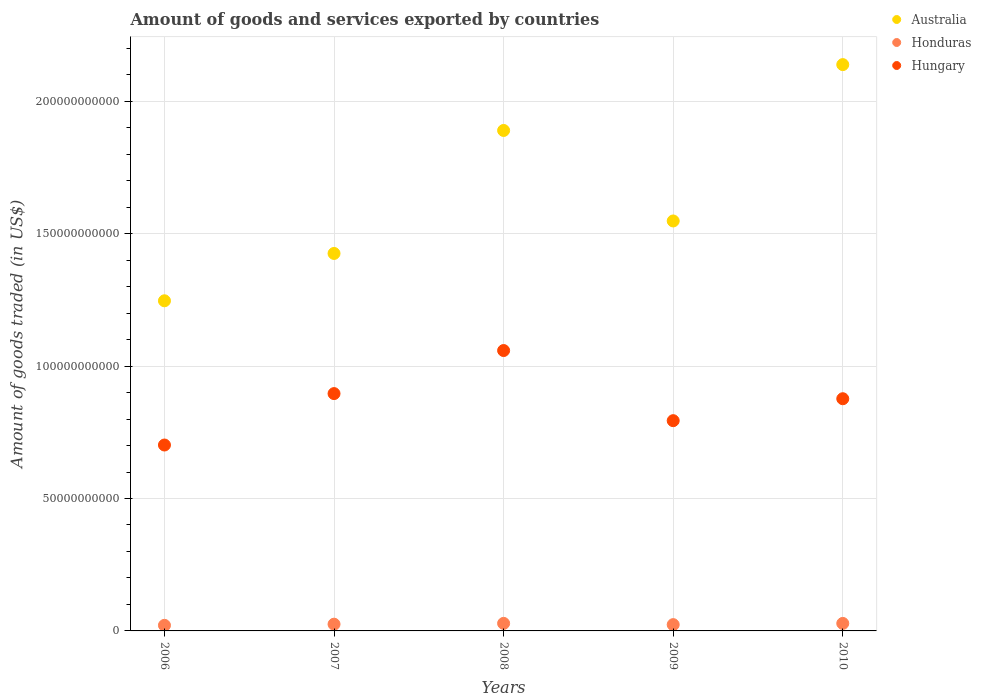How many different coloured dotlines are there?
Make the answer very short. 3. What is the total amount of goods and services exported in Honduras in 2007?
Offer a terse response. 2.54e+09. Across all years, what is the maximum total amount of goods and services exported in Honduras?
Provide a short and direct response. 2.85e+09. Across all years, what is the minimum total amount of goods and services exported in Australia?
Offer a very short reply. 1.25e+11. In which year was the total amount of goods and services exported in Honduras maximum?
Make the answer very short. 2008. What is the total total amount of goods and services exported in Australia in the graph?
Your answer should be very brief. 8.25e+11. What is the difference between the total amount of goods and services exported in Australia in 2007 and that in 2008?
Provide a succinct answer. -4.64e+1. What is the difference between the total amount of goods and services exported in Honduras in 2006 and the total amount of goods and services exported in Australia in 2008?
Offer a terse response. -1.87e+11. What is the average total amount of goods and services exported in Honduras per year?
Your answer should be compact. 2.54e+09. In the year 2009, what is the difference between the total amount of goods and services exported in Australia and total amount of goods and services exported in Hungary?
Make the answer very short. 7.54e+1. What is the ratio of the total amount of goods and services exported in Hungary in 2008 to that in 2009?
Ensure brevity in your answer.  1.33. Is the total amount of goods and services exported in Australia in 2006 less than that in 2007?
Your answer should be compact. Yes. What is the difference between the highest and the second highest total amount of goods and services exported in Hungary?
Your answer should be compact. 1.63e+1. What is the difference between the highest and the lowest total amount of goods and services exported in Honduras?
Ensure brevity in your answer.  7.39e+08. In how many years, is the total amount of goods and services exported in Honduras greater than the average total amount of goods and services exported in Honduras taken over all years?
Your response must be concise. 3. Does the total amount of goods and services exported in Australia monotonically increase over the years?
Provide a succinct answer. No. Is the total amount of goods and services exported in Honduras strictly greater than the total amount of goods and services exported in Hungary over the years?
Give a very brief answer. No. Is the total amount of goods and services exported in Hungary strictly less than the total amount of goods and services exported in Honduras over the years?
Provide a succinct answer. No. How many years are there in the graph?
Provide a succinct answer. 5. Does the graph contain any zero values?
Ensure brevity in your answer.  No. Does the graph contain grids?
Your response must be concise. Yes. Where does the legend appear in the graph?
Provide a short and direct response. Top right. What is the title of the graph?
Your answer should be compact. Amount of goods and services exported by countries. What is the label or title of the Y-axis?
Make the answer very short. Amount of goods traded (in US$). What is the Amount of goods traded (in US$) of Australia in 2006?
Make the answer very short. 1.25e+11. What is the Amount of goods traded (in US$) of Honduras in 2006?
Give a very brief answer. 2.11e+09. What is the Amount of goods traded (in US$) of Hungary in 2006?
Provide a succinct answer. 7.02e+1. What is the Amount of goods traded (in US$) in Australia in 2007?
Keep it short and to the point. 1.43e+11. What is the Amount of goods traded (in US$) in Honduras in 2007?
Your response must be concise. 2.54e+09. What is the Amount of goods traded (in US$) in Hungary in 2007?
Keep it short and to the point. 8.96e+1. What is the Amount of goods traded (in US$) in Australia in 2008?
Provide a succinct answer. 1.89e+11. What is the Amount of goods traded (in US$) of Honduras in 2008?
Ensure brevity in your answer.  2.85e+09. What is the Amount of goods traded (in US$) of Hungary in 2008?
Your answer should be compact. 1.06e+11. What is the Amount of goods traded (in US$) in Australia in 2009?
Keep it short and to the point. 1.55e+11. What is the Amount of goods traded (in US$) of Honduras in 2009?
Your answer should be compact. 2.38e+09. What is the Amount of goods traded (in US$) in Hungary in 2009?
Make the answer very short. 7.94e+1. What is the Amount of goods traded (in US$) of Australia in 2010?
Your answer should be very brief. 2.14e+11. What is the Amount of goods traded (in US$) of Honduras in 2010?
Make the answer very short. 2.83e+09. What is the Amount of goods traded (in US$) of Hungary in 2010?
Provide a succinct answer. 8.77e+1. Across all years, what is the maximum Amount of goods traded (in US$) in Australia?
Provide a succinct answer. 2.14e+11. Across all years, what is the maximum Amount of goods traded (in US$) in Honduras?
Your response must be concise. 2.85e+09. Across all years, what is the maximum Amount of goods traded (in US$) of Hungary?
Keep it short and to the point. 1.06e+11. Across all years, what is the minimum Amount of goods traded (in US$) in Australia?
Provide a succinct answer. 1.25e+11. Across all years, what is the minimum Amount of goods traded (in US$) in Honduras?
Provide a short and direct response. 2.11e+09. Across all years, what is the minimum Amount of goods traded (in US$) of Hungary?
Provide a succinct answer. 7.02e+1. What is the total Amount of goods traded (in US$) of Australia in the graph?
Provide a succinct answer. 8.25e+11. What is the total Amount of goods traded (in US$) of Honduras in the graph?
Ensure brevity in your answer.  1.27e+1. What is the total Amount of goods traded (in US$) of Hungary in the graph?
Your answer should be very brief. 4.33e+11. What is the difference between the Amount of goods traded (in US$) in Australia in 2006 and that in 2007?
Offer a very short reply. -1.79e+1. What is the difference between the Amount of goods traded (in US$) of Honduras in 2006 and that in 2007?
Keep it short and to the point. -4.34e+08. What is the difference between the Amount of goods traded (in US$) of Hungary in 2006 and that in 2007?
Your response must be concise. -1.94e+1. What is the difference between the Amount of goods traded (in US$) of Australia in 2006 and that in 2008?
Provide a succinct answer. -6.43e+1. What is the difference between the Amount of goods traded (in US$) of Honduras in 2006 and that in 2008?
Give a very brief answer. -7.39e+08. What is the difference between the Amount of goods traded (in US$) of Hungary in 2006 and that in 2008?
Give a very brief answer. -3.57e+1. What is the difference between the Amount of goods traded (in US$) of Australia in 2006 and that in 2009?
Keep it short and to the point. -3.01e+1. What is the difference between the Amount of goods traded (in US$) of Honduras in 2006 and that in 2009?
Ensure brevity in your answer.  -2.66e+08. What is the difference between the Amount of goods traded (in US$) in Hungary in 2006 and that in 2009?
Your answer should be compact. -9.19e+09. What is the difference between the Amount of goods traded (in US$) in Australia in 2006 and that in 2010?
Offer a terse response. -8.92e+1. What is the difference between the Amount of goods traded (in US$) in Honduras in 2006 and that in 2010?
Offer a very short reply. -7.23e+08. What is the difference between the Amount of goods traded (in US$) in Hungary in 2006 and that in 2010?
Ensure brevity in your answer.  -1.75e+1. What is the difference between the Amount of goods traded (in US$) of Australia in 2007 and that in 2008?
Your answer should be compact. -4.64e+1. What is the difference between the Amount of goods traded (in US$) in Honduras in 2007 and that in 2008?
Ensure brevity in your answer.  -3.05e+08. What is the difference between the Amount of goods traded (in US$) of Hungary in 2007 and that in 2008?
Your answer should be compact. -1.63e+1. What is the difference between the Amount of goods traded (in US$) of Australia in 2007 and that in 2009?
Give a very brief answer. -1.23e+1. What is the difference between the Amount of goods traded (in US$) in Honduras in 2007 and that in 2009?
Your answer should be compact. 1.68e+08. What is the difference between the Amount of goods traded (in US$) of Hungary in 2007 and that in 2009?
Your answer should be very brief. 1.02e+1. What is the difference between the Amount of goods traded (in US$) in Australia in 2007 and that in 2010?
Give a very brief answer. -7.13e+1. What is the difference between the Amount of goods traded (in US$) of Honduras in 2007 and that in 2010?
Offer a very short reply. -2.89e+08. What is the difference between the Amount of goods traded (in US$) in Hungary in 2007 and that in 2010?
Your response must be concise. 1.94e+09. What is the difference between the Amount of goods traded (in US$) of Australia in 2008 and that in 2009?
Provide a short and direct response. 3.42e+1. What is the difference between the Amount of goods traded (in US$) in Honduras in 2008 and that in 2009?
Your answer should be very brief. 4.73e+08. What is the difference between the Amount of goods traded (in US$) in Hungary in 2008 and that in 2009?
Keep it short and to the point. 2.65e+1. What is the difference between the Amount of goods traded (in US$) of Australia in 2008 and that in 2010?
Make the answer very short. -2.49e+1. What is the difference between the Amount of goods traded (in US$) of Honduras in 2008 and that in 2010?
Offer a terse response. 1.64e+07. What is the difference between the Amount of goods traded (in US$) in Hungary in 2008 and that in 2010?
Your answer should be compact. 1.82e+1. What is the difference between the Amount of goods traded (in US$) of Australia in 2009 and that in 2010?
Provide a succinct answer. -5.90e+1. What is the difference between the Amount of goods traded (in US$) of Honduras in 2009 and that in 2010?
Your response must be concise. -4.57e+08. What is the difference between the Amount of goods traded (in US$) in Hungary in 2009 and that in 2010?
Give a very brief answer. -8.29e+09. What is the difference between the Amount of goods traded (in US$) of Australia in 2006 and the Amount of goods traded (in US$) of Honduras in 2007?
Ensure brevity in your answer.  1.22e+11. What is the difference between the Amount of goods traded (in US$) in Australia in 2006 and the Amount of goods traded (in US$) in Hungary in 2007?
Keep it short and to the point. 3.50e+1. What is the difference between the Amount of goods traded (in US$) in Honduras in 2006 and the Amount of goods traded (in US$) in Hungary in 2007?
Your answer should be very brief. -8.75e+1. What is the difference between the Amount of goods traded (in US$) of Australia in 2006 and the Amount of goods traded (in US$) of Honduras in 2008?
Ensure brevity in your answer.  1.22e+11. What is the difference between the Amount of goods traded (in US$) of Australia in 2006 and the Amount of goods traded (in US$) of Hungary in 2008?
Provide a succinct answer. 1.88e+1. What is the difference between the Amount of goods traded (in US$) of Honduras in 2006 and the Amount of goods traded (in US$) of Hungary in 2008?
Give a very brief answer. -1.04e+11. What is the difference between the Amount of goods traded (in US$) of Australia in 2006 and the Amount of goods traded (in US$) of Honduras in 2009?
Provide a succinct answer. 1.22e+11. What is the difference between the Amount of goods traded (in US$) of Australia in 2006 and the Amount of goods traded (in US$) of Hungary in 2009?
Ensure brevity in your answer.  4.53e+1. What is the difference between the Amount of goods traded (in US$) in Honduras in 2006 and the Amount of goods traded (in US$) in Hungary in 2009?
Ensure brevity in your answer.  -7.73e+1. What is the difference between the Amount of goods traded (in US$) of Australia in 2006 and the Amount of goods traded (in US$) of Honduras in 2010?
Offer a terse response. 1.22e+11. What is the difference between the Amount of goods traded (in US$) of Australia in 2006 and the Amount of goods traded (in US$) of Hungary in 2010?
Your answer should be very brief. 3.70e+1. What is the difference between the Amount of goods traded (in US$) of Honduras in 2006 and the Amount of goods traded (in US$) of Hungary in 2010?
Make the answer very short. -8.56e+1. What is the difference between the Amount of goods traded (in US$) in Australia in 2007 and the Amount of goods traded (in US$) in Honduras in 2008?
Your answer should be compact. 1.40e+11. What is the difference between the Amount of goods traded (in US$) of Australia in 2007 and the Amount of goods traded (in US$) of Hungary in 2008?
Ensure brevity in your answer.  3.67e+1. What is the difference between the Amount of goods traded (in US$) in Honduras in 2007 and the Amount of goods traded (in US$) in Hungary in 2008?
Make the answer very short. -1.03e+11. What is the difference between the Amount of goods traded (in US$) of Australia in 2007 and the Amount of goods traded (in US$) of Honduras in 2009?
Your response must be concise. 1.40e+11. What is the difference between the Amount of goods traded (in US$) of Australia in 2007 and the Amount of goods traded (in US$) of Hungary in 2009?
Your response must be concise. 6.31e+1. What is the difference between the Amount of goods traded (in US$) in Honduras in 2007 and the Amount of goods traded (in US$) in Hungary in 2009?
Give a very brief answer. -7.68e+1. What is the difference between the Amount of goods traded (in US$) of Australia in 2007 and the Amount of goods traded (in US$) of Honduras in 2010?
Provide a short and direct response. 1.40e+11. What is the difference between the Amount of goods traded (in US$) in Australia in 2007 and the Amount of goods traded (in US$) in Hungary in 2010?
Give a very brief answer. 5.48e+1. What is the difference between the Amount of goods traded (in US$) in Honduras in 2007 and the Amount of goods traded (in US$) in Hungary in 2010?
Keep it short and to the point. -8.51e+1. What is the difference between the Amount of goods traded (in US$) of Australia in 2008 and the Amount of goods traded (in US$) of Honduras in 2009?
Provide a succinct answer. 1.87e+11. What is the difference between the Amount of goods traded (in US$) of Australia in 2008 and the Amount of goods traded (in US$) of Hungary in 2009?
Make the answer very short. 1.10e+11. What is the difference between the Amount of goods traded (in US$) in Honduras in 2008 and the Amount of goods traded (in US$) in Hungary in 2009?
Your response must be concise. -7.65e+1. What is the difference between the Amount of goods traded (in US$) in Australia in 2008 and the Amount of goods traded (in US$) in Honduras in 2010?
Your answer should be compact. 1.86e+11. What is the difference between the Amount of goods traded (in US$) of Australia in 2008 and the Amount of goods traded (in US$) of Hungary in 2010?
Your response must be concise. 1.01e+11. What is the difference between the Amount of goods traded (in US$) of Honduras in 2008 and the Amount of goods traded (in US$) of Hungary in 2010?
Provide a succinct answer. -8.48e+1. What is the difference between the Amount of goods traded (in US$) in Australia in 2009 and the Amount of goods traded (in US$) in Honduras in 2010?
Keep it short and to the point. 1.52e+11. What is the difference between the Amount of goods traded (in US$) in Australia in 2009 and the Amount of goods traded (in US$) in Hungary in 2010?
Offer a very short reply. 6.71e+1. What is the difference between the Amount of goods traded (in US$) in Honduras in 2009 and the Amount of goods traded (in US$) in Hungary in 2010?
Offer a terse response. -8.53e+1. What is the average Amount of goods traded (in US$) of Australia per year?
Provide a short and direct response. 1.65e+11. What is the average Amount of goods traded (in US$) of Honduras per year?
Make the answer very short. 2.54e+09. What is the average Amount of goods traded (in US$) in Hungary per year?
Ensure brevity in your answer.  8.65e+1. In the year 2006, what is the difference between the Amount of goods traded (in US$) in Australia and Amount of goods traded (in US$) in Honduras?
Ensure brevity in your answer.  1.23e+11. In the year 2006, what is the difference between the Amount of goods traded (in US$) of Australia and Amount of goods traded (in US$) of Hungary?
Your answer should be very brief. 5.45e+1. In the year 2006, what is the difference between the Amount of goods traded (in US$) in Honduras and Amount of goods traded (in US$) in Hungary?
Your answer should be compact. -6.81e+1. In the year 2007, what is the difference between the Amount of goods traded (in US$) in Australia and Amount of goods traded (in US$) in Honduras?
Your answer should be very brief. 1.40e+11. In the year 2007, what is the difference between the Amount of goods traded (in US$) of Australia and Amount of goods traded (in US$) of Hungary?
Make the answer very short. 5.29e+1. In the year 2007, what is the difference between the Amount of goods traded (in US$) of Honduras and Amount of goods traded (in US$) of Hungary?
Your answer should be very brief. -8.71e+1. In the year 2008, what is the difference between the Amount of goods traded (in US$) in Australia and Amount of goods traded (in US$) in Honduras?
Your answer should be very brief. 1.86e+11. In the year 2008, what is the difference between the Amount of goods traded (in US$) of Australia and Amount of goods traded (in US$) of Hungary?
Ensure brevity in your answer.  8.31e+1. In the year 2008, what is the difference between the Amount of goods traded (in US$) of Honduras and Amount of goods traded (in US$) of Hungary?
Your answer should be compact. -1.03e+11. In the year 2009, what is the difference between the Amount of goods traded (in US$) in Australia and Amount of goods traded (in US$) in Honduras?
Give a very brief answer. 1.52e+11. In the year 2009, what is the difference between the Amount of goods traded (in US$) of Australia and Amount of goods traded (in US$) of Hungary?
Provide a succinct answer. 7.54e+1. In the year 2009, what is the difference between the Amount of goods traded (in US$) of Honduras and Amount of goods traded (in US$) of Hungary?
Offer a terse response. -7.70e+1. In the year 2010, what is the difference between the Amount of goods traded (in US$) in Australia and Amount of goods traded (in US$) in Honduras?
Your answer should be very brief. 2.11e+11. In the year 2010, what is the difference between the Amount of goods traded (in US$) of Australia and Amount of goods traded (in US$) of Hungary?
Your answer should be compact. 1.26e+11. In the year 2010, what is the difference between the Amount of goods traded (in US$) in Honduras and Amount of goods traded (in US$) in Hungary?
Offer a terse response. -8.48e+1. What is the ratio of the Amount of goods traded (in US$) of Australia in 2006 to that in 2007?
Offer a very short reply. 0.87. What is the ratio of the Amount of goods traded (in US$) of Honduras in 2006 to that in 2007?
Your answer should be very brief. 0.83. What is the ratio of the Amount of goods traded (in US$) in Hungary in 2006 to that in 2007?
Offer a terse response. 0.78. What is the ratio of the Amount of goods traded (in US$) of Australia in 2006 to that in 2008?
Offer a terse response. 0.66. What is the ratio of the Amount of goods traded (in US$) in Honduras in 2006 to that in 2008?
Ensure brevity in your answer.  0.74. What is the ratio of the Amount of goods traded (in US$) of Hungary in 2006 to that in 2008?
Make the answer very short. 0.66. What is the ratio of the Amount of goods traded (in US$) in Australia in 2006 to that in 2009?
Your answer should be very brief. 0.81. What is the ratio of the Amount of goods traded (in US$) of Honduras in 2006 to that in 2009?
Offer a terse response. 0.89. What is the ratio of the Amount of goods traded (in US$) in Hungary in 2006 to that in 2009?
Give a very brief answer. 0.88. What is the ratio of the Amount of goods traded (in US$) in Australia in 2006 to that in 2010?
Your answer should be very brief. 0.58. What is the ratio of the Amount of goods traded (in US$) of Honduras in 2006 to that in 2010?
Offer a very short reply. 0.74. What is the ratio of the Amount of goods traded (in US$) in Hungary in 2006 to that in 2010?
Provide a short and direct response. 0.8. What is the ratio of the Amount of goods traded (in US$) of Australia in 2007 to that in 2008?
Provide a succinct answer. 0.75. What is the ratio of the Amount of goods traded (in US$) of Honduras in 2007 to that in 2008?
Keep it short and to the point. 0.89. What is the ratio of the Amount of goods traded (in US$) of Hungary in 2007 to that in 2008?
Your response must be concise. 0.85. What is the ratio of the Amount of goods traded (in US$) of Australia in 2007 to that in 2009?
Your response must be concise. 0.92. What is the ratio of the Amount of goods traded (in US$) of Honduras in 2007 to that in 2009?
Your answer should be very brief. 1.07. What is the ratio of the Amount of goods traded (in US$) of Hungary in 2007 to that in 2009?
Your response must be concise. 1.13. What is the ratio of the Amount of goods traded (in US$) of Australia in 2007 to that in 2010?
Your answer should be very brief. 0.67. What is the ratio of the Amount of goods traded (in US$) of Honduras in 2007 to that in 2010?
Provide a short and direct response. 0.9. What is the ratio of the Amount of goods traded (in US$) in Hungary in 2007 to that in 2010?
Give a very brief answer. 1.02. What is the ratio of the Amount of goods traded (in US$) in Australia in 2008 to that in 2009?
Offer a terse response. 1.22. What is the ratio of the Amount of goods traded (in US$) in Honduras in 2008 to that in 2009?
Provide a succinct answer. 1.2. What is the ratio of the Amount of goods traded (in US$) of Hungary in 2008 to that in 2009?
Your answer should be compact. 1.33. What is the ratio of the Amount of goods traded (in US$) in Australia in 2008 to that in 2010?
Offer a very short reply. 0.88. What is the ratio of the Amount of goods traded (in US$) in Honduras in 2008 to that in 2010?
Offer a terse response. 1.01. What is the ratio of the Amount of goods traded (in US$) of Hungary in 2008 to that in 2010?
Your response must be concise. 1.21. What is the ratio of the Amount of goods traded (in US$) in Australia in 2009 to that in 2010?
Your answer should be compact. 0.72. What is the ratio of the Amount of goods traded (in US$) in Honduras in 2009 to that in 2010?
Offer a very short reply. 0.84. What is the ratio of the Amount of goods traded (in US$) of Hungary in 2009 to that in 2010?
Your answer should be very brief. 0.91. What is the difference between the highest and the second highest Amount of goods traded (in US$) in Australia?
Offer a terse response. 2.49e+1. What is the difference between the highest and the second highest Amount of goods traded (in US$) of Honduras?
Offer a terse response. 1.64e+07. What is the difference between the highest and the second highest Amount of goods traded (in US$) of Hungary?
Your answer should be compact. 1.63e+1. What is the difference between the highest and the lowest Amount of goods traded (in US$) of Australia?
Offer a very short reply. 8.92e+1. What is the difference between the highest and the lowest Amount of goods traded (in US$) of Honduras?
Your answer should be very brief. 7.39e+08. What is the difference between the highest and the lowest Amount of goods traded (in US$) of Hungary?
Your response must be concise. 3.57e+1. 